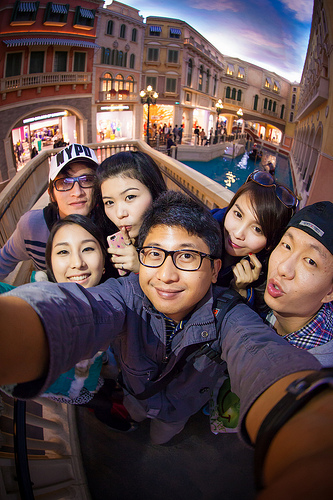<image>
Is the glasses on the girl? No. The glasses is not positioned on the girl. They may be near each other, but the glasses is not supported by or resting on top of the girl. Is there a man to the left of the woman? No. The man is not to the left of the woman. From this viewpoint, they have a different horizontal relationship. 